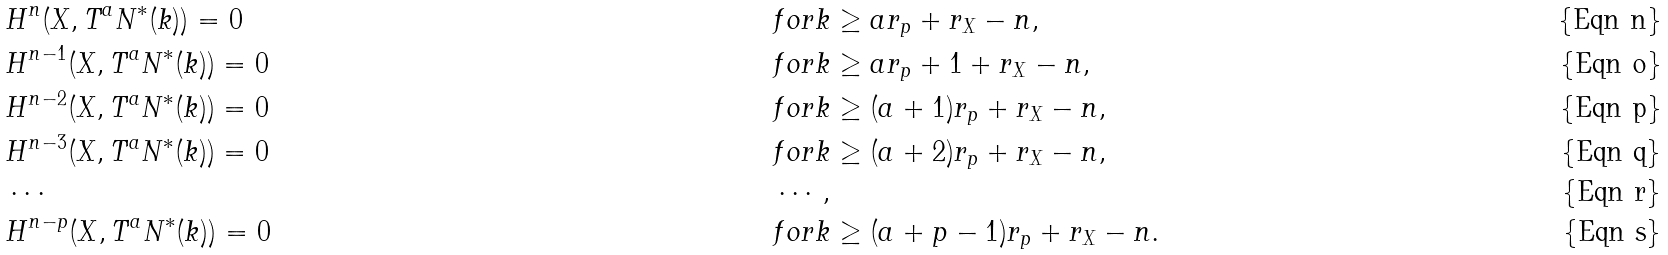Convert formula to latex. <formula><loc_0><loc_0><loc_500><loc_500>& H ^ { n } ( X , T ^ { a } N ^ { * } ( k ) ) = 0 & & f o r k \geq a r _ { p } + r _ { X } - n , \\ & H ^ { n - 1 } ( X , T ^ { a } N ^ { * } ( k ) ) = 0 & & f o r k \geq a r _ { p } + 1 + r _ { X } - n , \\ & H ^ { n - 2 } ( X , T ^ { a } N ^ { * } ( k ) ) = 0 & & f o r k \geq ( a + 1 ) r _ { p } + r _ { X } - n , \\ & H ^ { n - 3 } ( X , T ^ { a } N ^ { * } ( k ) ) = 0 & & f o r k \geq ( a + 2 ) r _ { p } + r _ { X } - n , \\ & \cdots & & \cdots , \\ & H ^ { n - p } ( X , T ^ { a } N ^ { * } ( k ) ) = 0 & & f o r k \geq ( a + p - 1 ) r _ { p } + r _ { X } - n .</formula> 